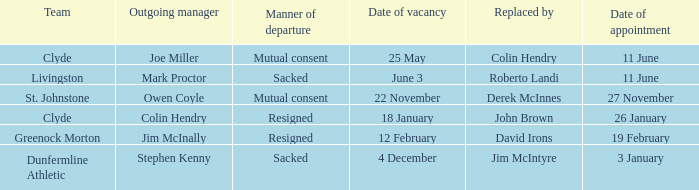Tell me the outgoing manager for 22 november date of vacancy Owen Coyle. 